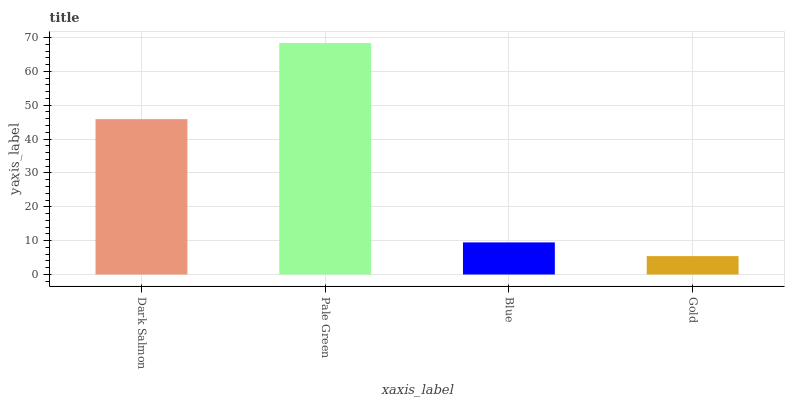Is Gold the minimum?
Answer yes or no. Yes. Is Pale Green the maximum?
Answer yes or no. Yes. Is Blue the minimum?
Answer yes or no. No. Is Blue the maximum?
Answer yes or no. No. Is Pale Green greater than Blue?
Answer yes or no. Yes. Is Blue less than Pale Green?
Answer yes or no. Yes. Is Blue greater than Pale Green?
Answer yes or no. No. Is Pale Green less than Blue?
Answer yes or no. No. Is Dark Salmon the high median?
Answer yes or no. Yes. Is Blue the low median?
Answer yes or no. Yes. Is Pale Green the high median?
Answer yes or no. No. Is Dark Salmon the low median?
Answer yes or no. No. 